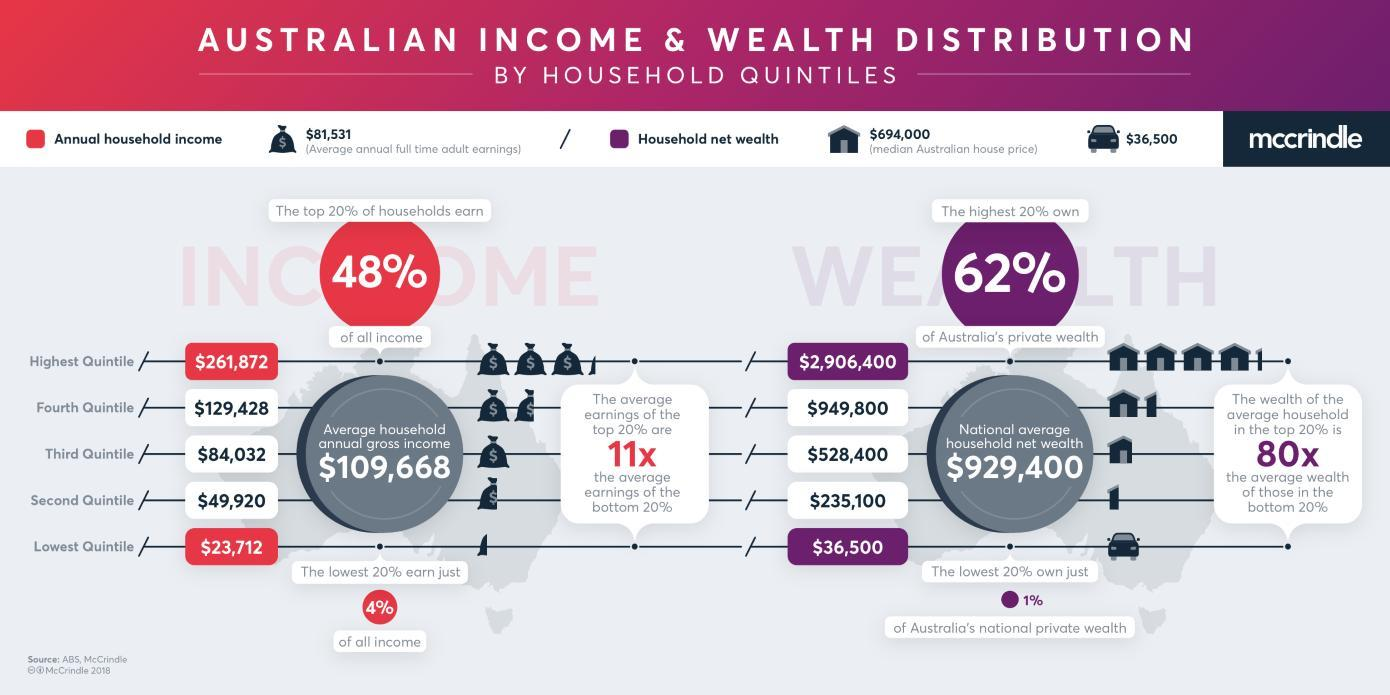How much does the fourth quintile earn more than the lowest Quintile?
Answer the question with a short phrase. $105,716 How much Australian national private wealth does the second quintile own more than the lowest Quintile? $198,600 How much does the third quintile earn more than the lowest Quintile? $60,320 How much does the second quintile earn more than the lowest Quintile? $26,208 